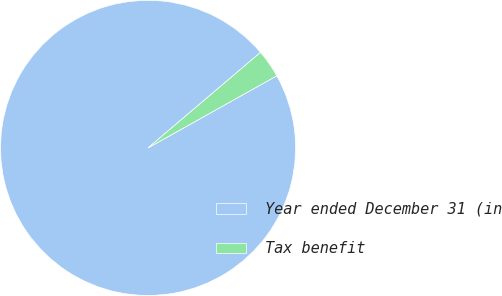<chart> <loc_0><loc_0><loc_500><loc_500><pie_chart><fcel>Year ended December 31 (in<fcel>Tax benefit<nl><fcel>96.92%<fcel>3.08%<nl></chart> 